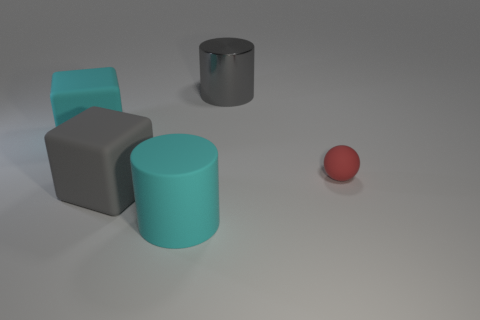What number of matte objects are red things or small blue objects?
Keep it short and to the point. 1. The large thing that is on the right side of the gray cube and in front of the small red thing is made of what material?
Ensure brevity in your answer.  Rubber. There is a object that is on the right side of the object behind the big cyan cube; are there any rubber cylinders right of it?
Your response must be concise. No. Are there any other things that have the same material as the gray cylinder?
Offer a very short reply. No. What is the shape of the red object that is made of the same material as the big cyan block?
Your answer should be very brief. Sphere. Is the number of matte cylinders that are behind the big gray metal thing less than the number of large gray cubes left of the tiny red matte object?
Your answer should be compact. Yes. How many big objects are gray matte objects or red rubber spheres?
Offer a very short reply. 1. There is a thing on the right side of the large gray metallic object; is it the same shape as the big cyan thing right of the gray cube?
Your answer should be very brief. No. What size is the red rubber object to the right of the big gray thing right of the cylinder left of the big gray metal cylinder?
Offer a terse response. Small. What size is the cylinder to the right of the matte cylinder?
Provide a short and direct response. Large. 